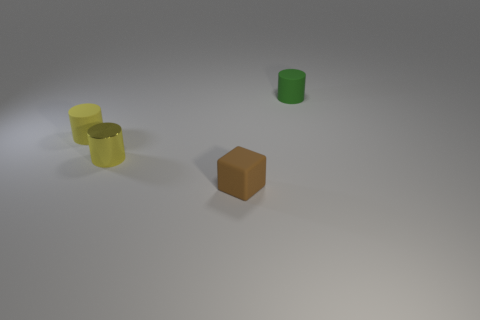Subtract all small yellow cylinders. How many cylinders are left? 1 Add 3 tiny green cylinders. How many objects exist? 7 Subtract all yellow cylinders. How many cylinders are left? 1 Subtract 0 green blocks. How many objects are left? 4 Subtract all cylinders. How many objects are left? 1 Subtract 2 cylinders. How many cylinders are left? 1 Subtract all yellow blocks. Subtract all yellow cylinders. How many blocks are left? 1 Subtract all cyan balls. How many green cylinders are left? 1 Subtract all tiny blue rubber spheres. Subtract all rubber cylinders. How many objects are left? 2 Add 3 small green rubber objects. How many small green rubber objects are left? 4 